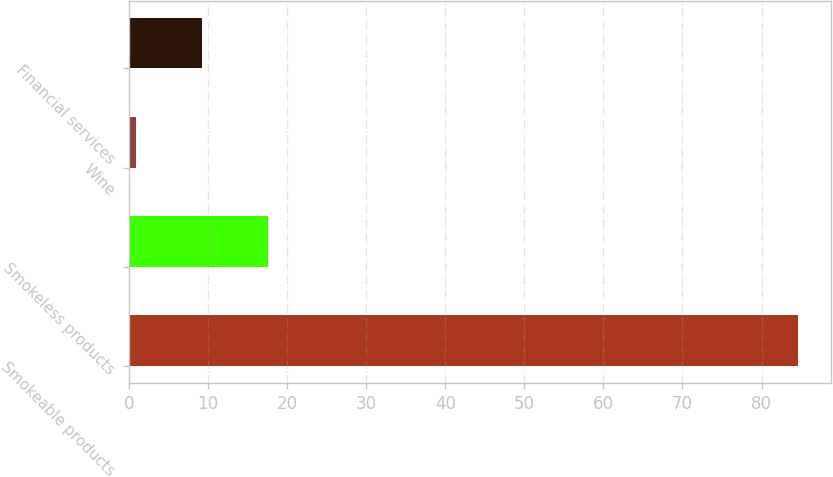Convert chart to OTSL. <chart><loc_0><loc_0><loc_500><loc_500><bar_chart><fcel>Smokeable products<fcel>Smokeless products<fcel>Wine<fcel>Financial services<nl><fcel>84.6<fcel>17.64<fcel>0.9<fcel>9.27<nl></chart> 